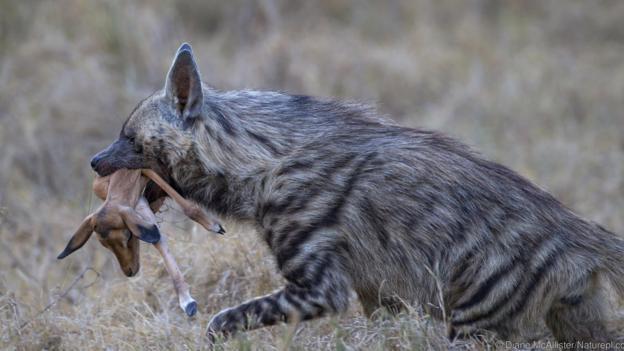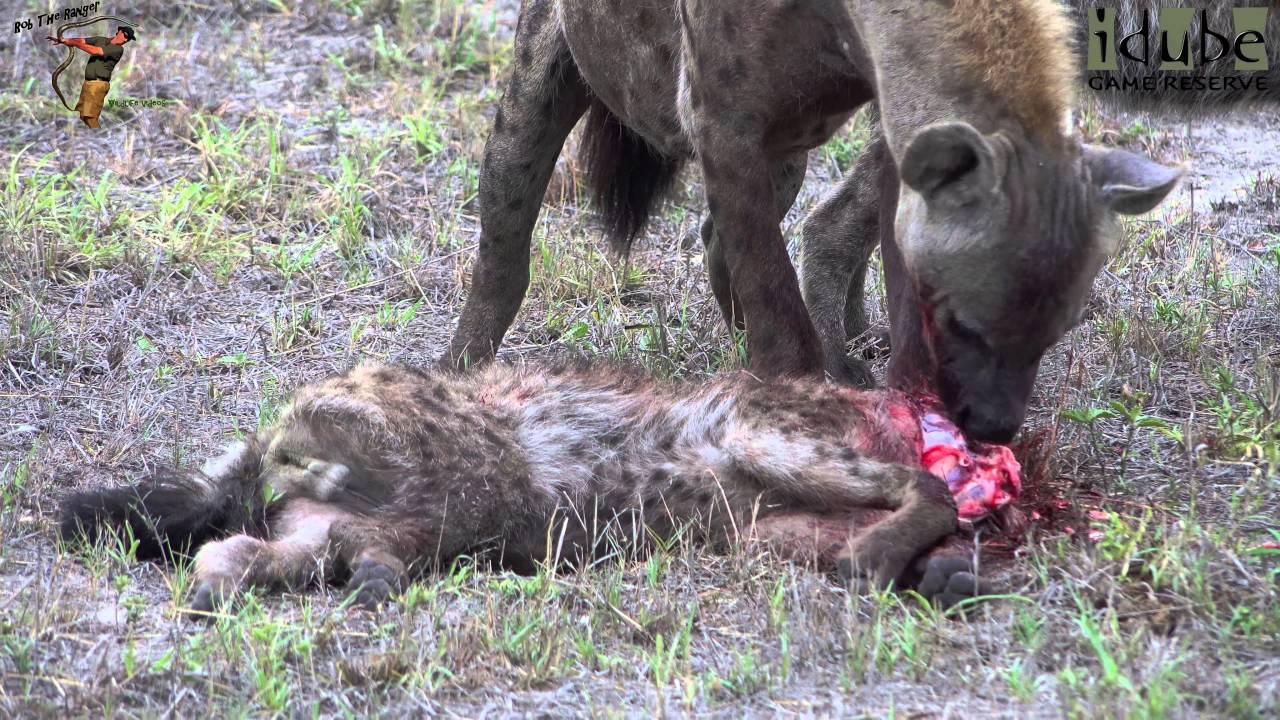The first image is the image on the left, the second image is the image on the right. For the images shown, is this caption "At least one image shows an upright young hyena with something that is not part of a prey animal held in its mouth." true? Answer yes or no. No. The first image is the image on the left, the second image is the image on the right. Considering the images on both sides, is "The left image contains two hyenas." valid? Answer yes or no. No. 